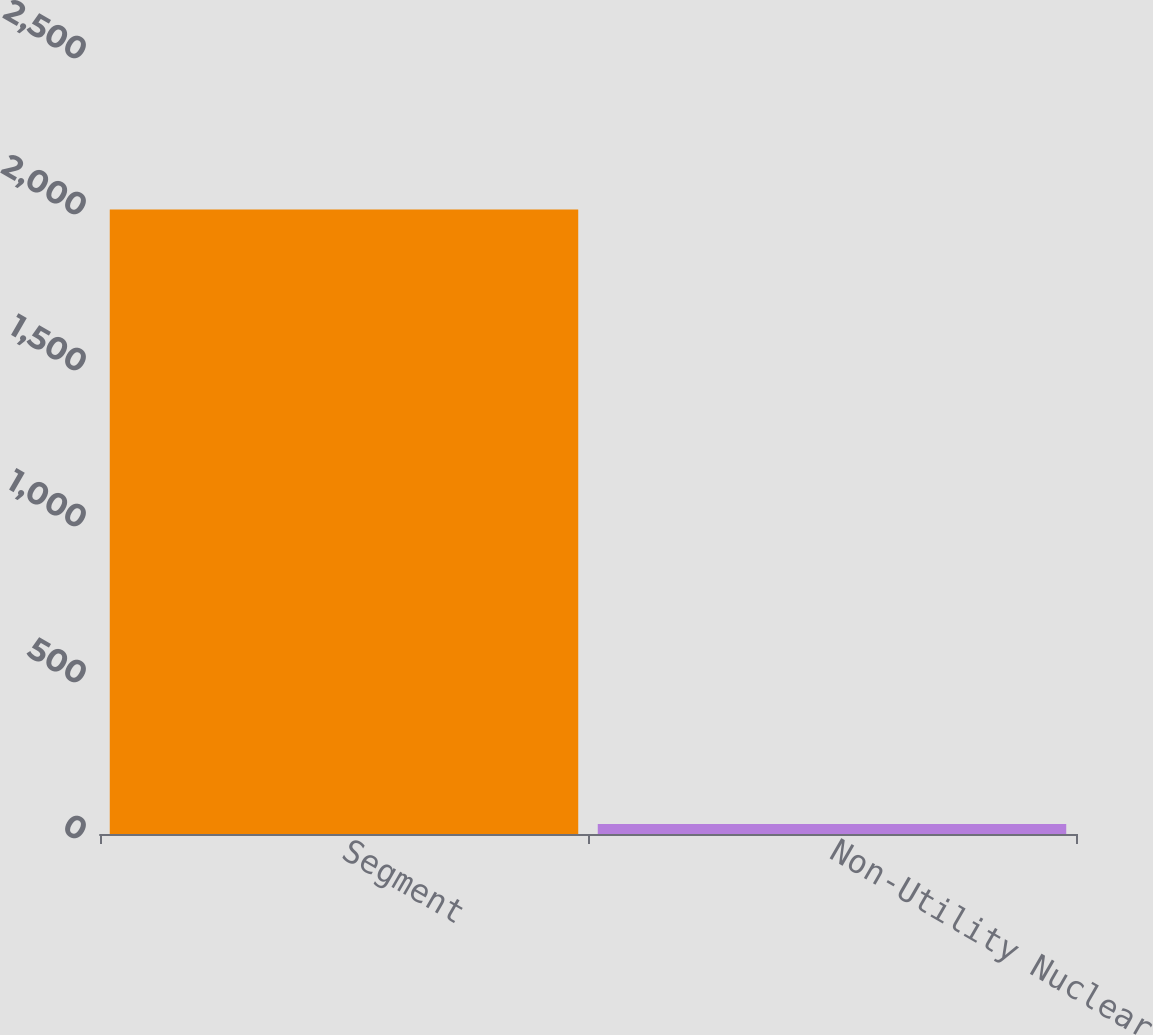Convert chart. <chart><loc_0><loc_0><loc_500><loc_500><bar_chart><fcel>Segment<fcel>Non-Utility Nuclear<nl><fcel>2002<fcel>32<nl></chart> 